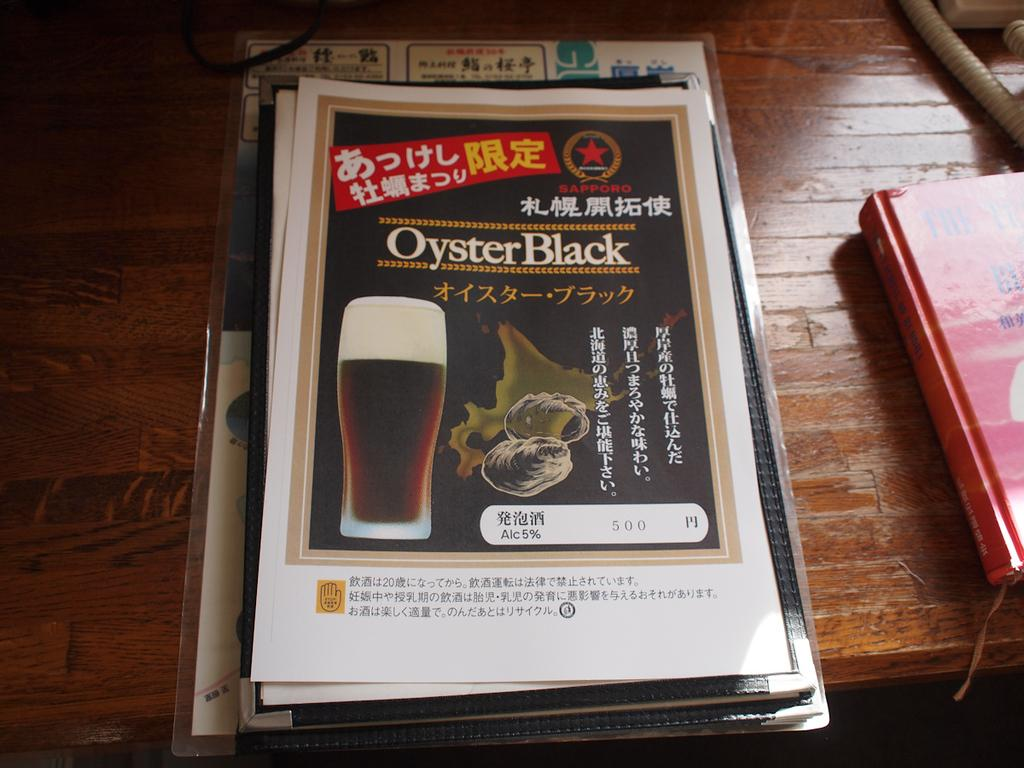<image>
Offer a succinct explanation of the picture presented. A menu cover with an image of a beer called Oyster Black. 